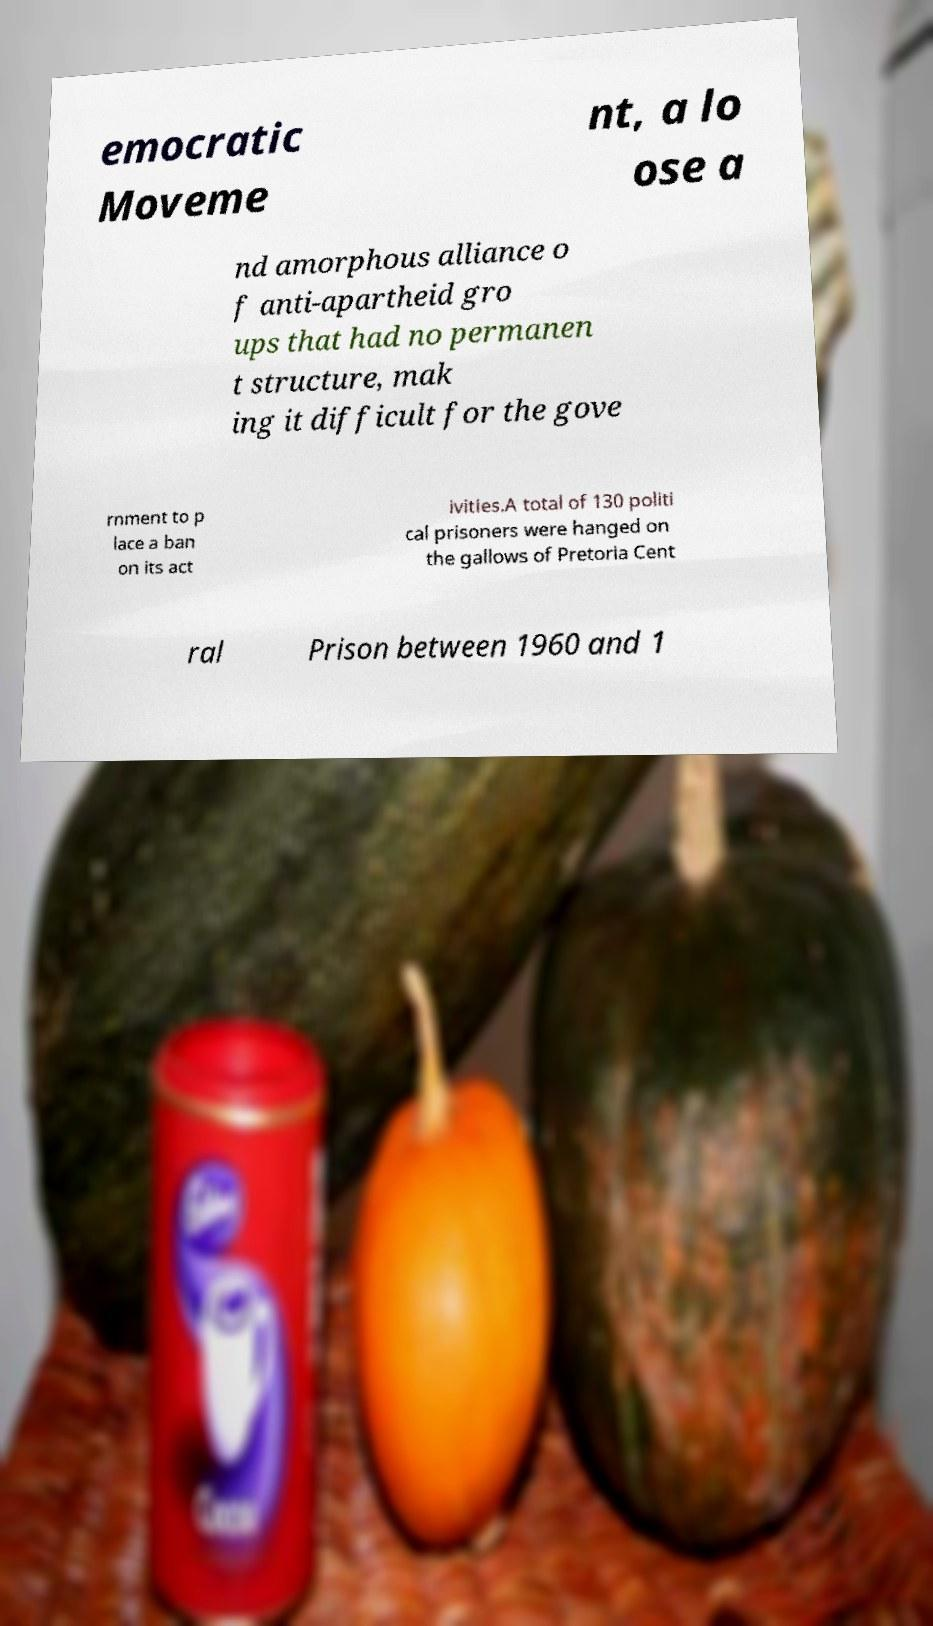What messages or text are displayed in this image? I need them in a readable, typed format. emocratic Moveme nt, a lo ose a nd amorphous alliance o f anti-apartheid gro ups that had no permanen t structure, mak ing it difficult for the gove rnment to p lace a ban on its act ivities.A total of 130 politi cal prisoners were hanged on the gallows of Pretoria Cent ral Prison between 1960 and 1 